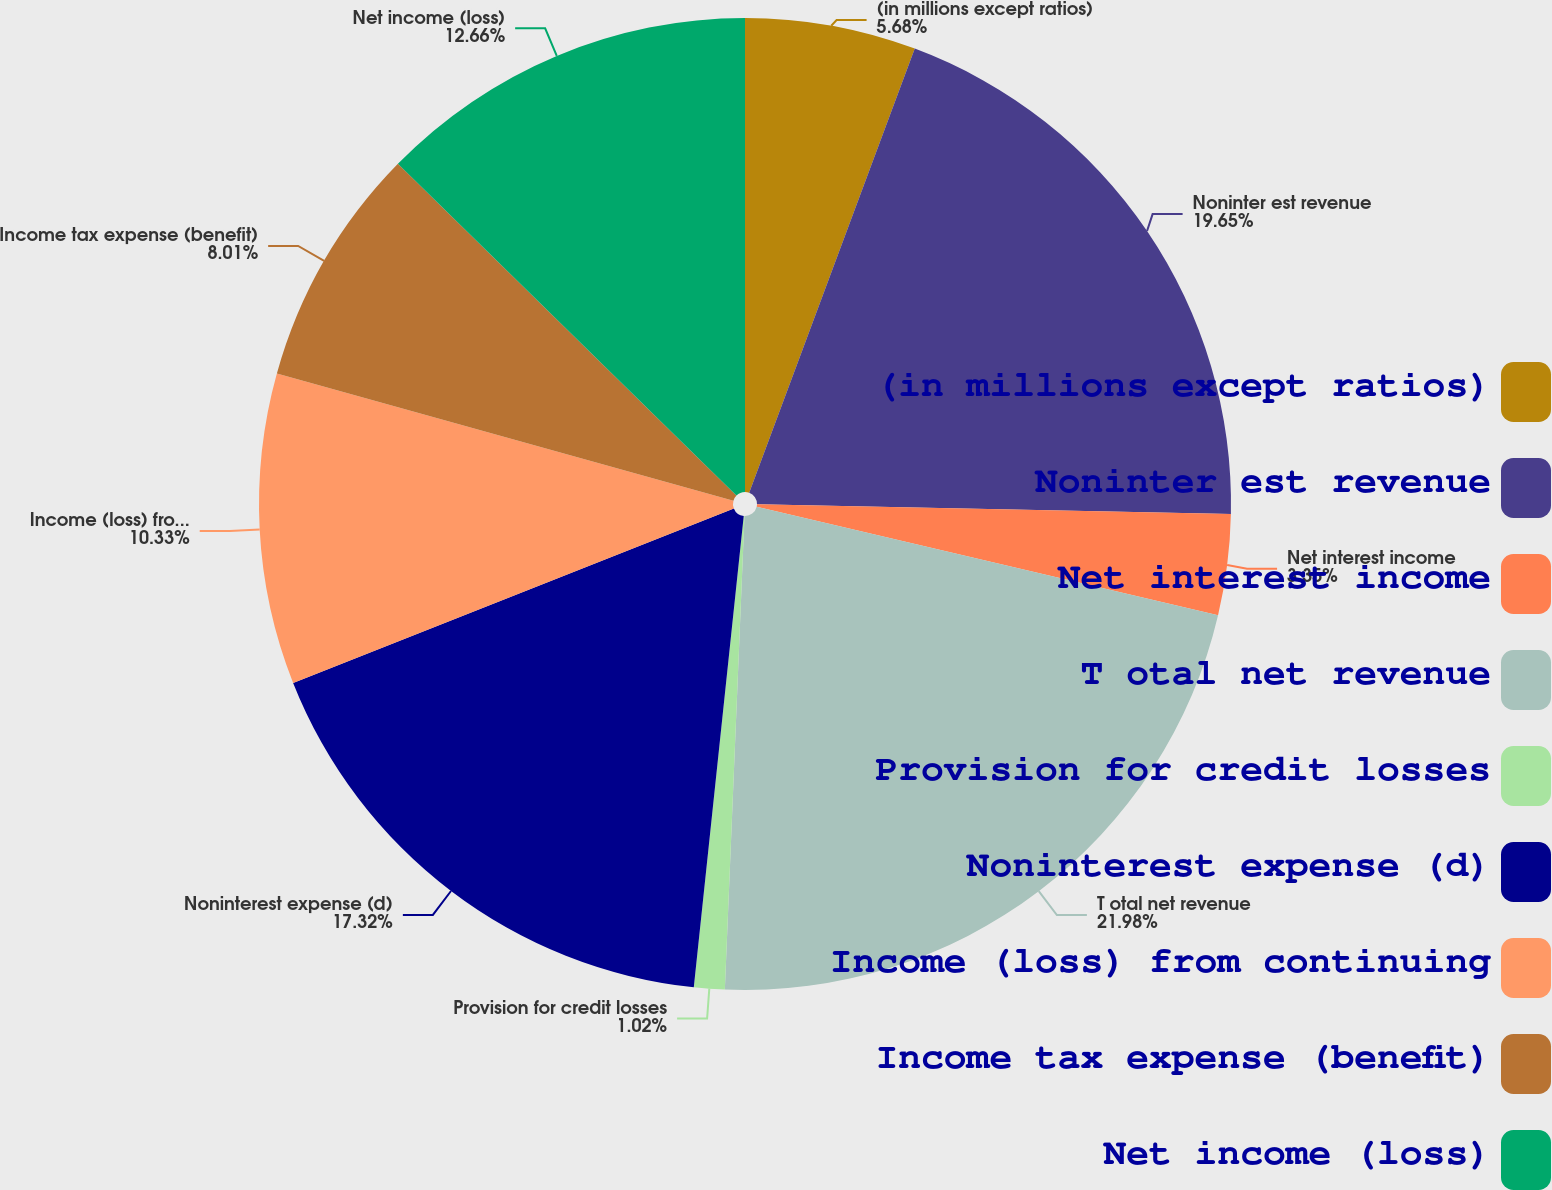Convert chart. <chart><loc_0><loc_0><loc_500><loc_500><pie_chart><fcel>(in millions except ratios)<fcel>Noninter est revenue<fcel>Net interest income<fcel>T otal net revenue<fcel>Provision for credit losses<fcel>Noninterest expense (d)<fcel>Income (loss) from continuing<fcel>Income tax expense (benefit)<fcel>Net income (loss)<nl><fcel>5.68%<fcel>19.65%<fcel>3.35%<fcel>21.98%<fcel>1.02%<fcel>17.32%<fcel>10.33%<fcel>8.01%<fcel>12.66%<nl></chart> 